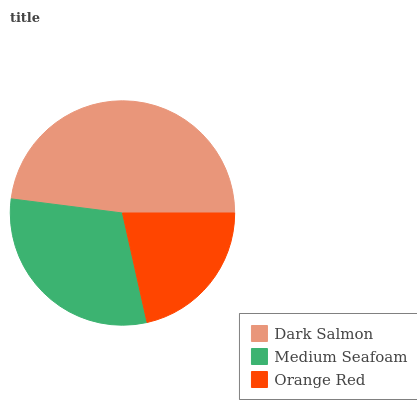Is Orange Red the minimum?
Answer yes or no. Yes. Is Dark Salmon the maximum?
Answer yes or no. Yes. Is Medium Seafoam the minimum?
Answer yes or no. No. Is Medium Seafoam the maximum?
Answer yes or no. No. Is Dark Salmon greater than Medium Seafoam?
Answer yes or no. Yes. Is Medium Seafoam less than Dark Salmon?
Answer yes or no. Yes. Is Medium Seafoam greater than Dark Salmon?
Answer yes or no. No. Is Dark Salmon less than Medium Seafoam?
Answer yes or no. No. Is Medium Seafoam the high median?
Answer yes or no. Yes. Is Medium Seafoam the low median?
Answer yes or no. Yes. Is Dark Salmon the high median?
Answer yes or no. No. Is Dark Salmon the low median?
Answer yes or no. No. 